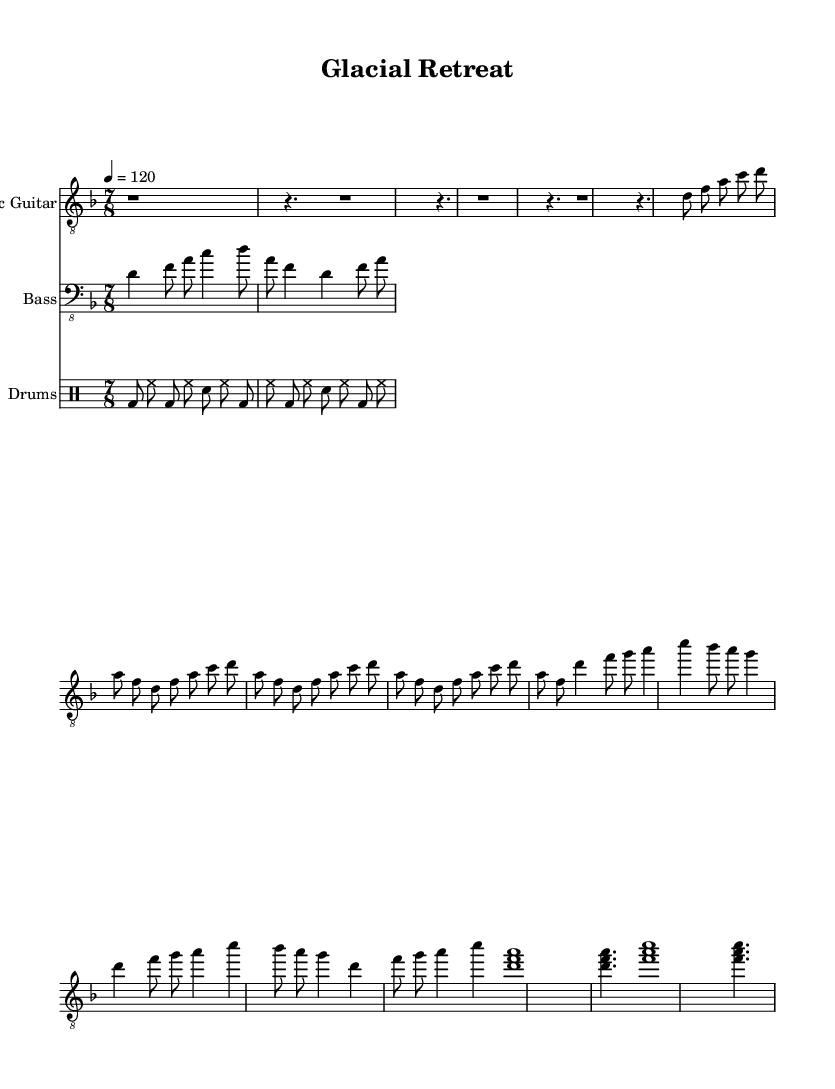What is the key signature of this music? The key signature is D minor, which has one flat (C).
Answer: D minor What is the time signature of this piece? The time signature is 7/8, meaning there are seven eighth notes per measure.
Answer: 7/8 What is the tempo of the piece? The tempo is set at 120 beats per minute, indicating that the music should be played at a moderate pace.
Answer: 120 How many measures are shown in the intro section? The intro section consists of 4 measures, as indicated by the repeated patterns shown before the verse section.
Answer: 4 Which instrument has the clef "bass_8"? The instrument that has "bass_8" is the Bass Guitar, which indicates it is played an octave higher in the notation.
Answer: Bass Guitar In what aspect does this piece reflect a progressive metal characteristic? The use of odd time signatures (7/8) along with complex guitar riffs showcases a typical progressive metal feature, allowing for intricate rhythms and experimentation.
Answer: 7/8 